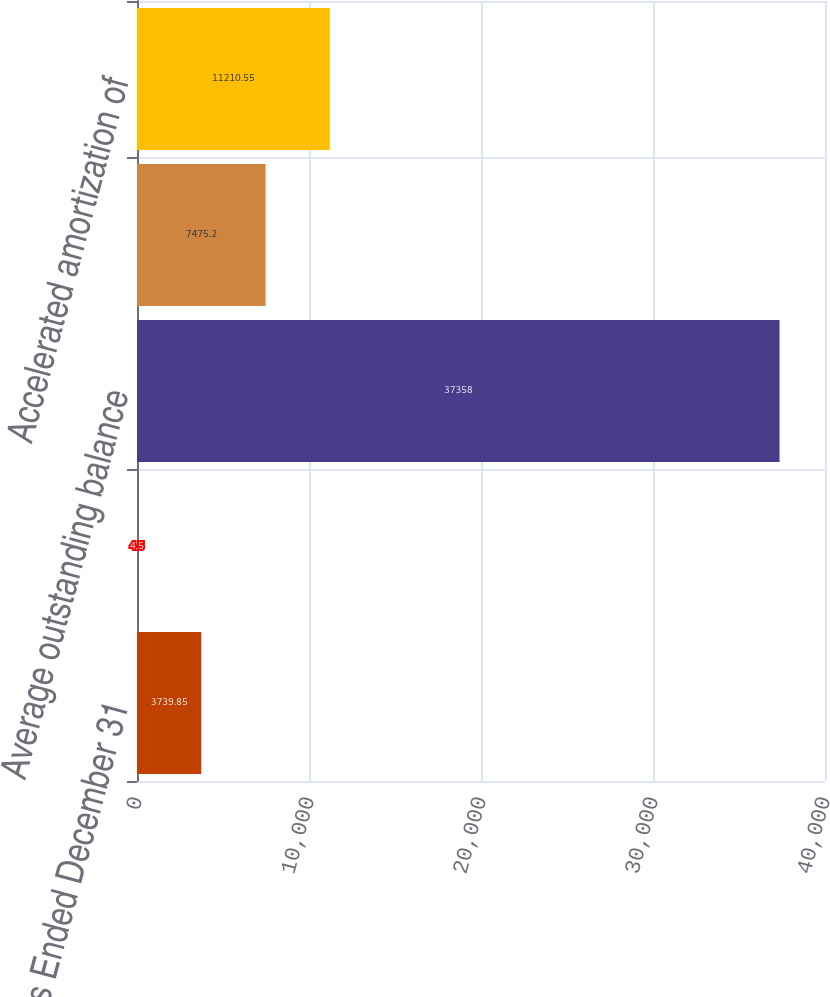Convert chart to OTSL. <chart><loc_0><loc_0><loc_500><loc_500><bar_chart><fcel>Years Ended December 31<fcel>Weighted average interest rate<fcel>Average outstanding balance<fcel>Periodic amortization of<fcel>Accelerated amortization of<nl><fcel>3739.85<fcel>4.5<fcel>37358<fcel>7475.2<fcel>11210.5<nl></chart> 